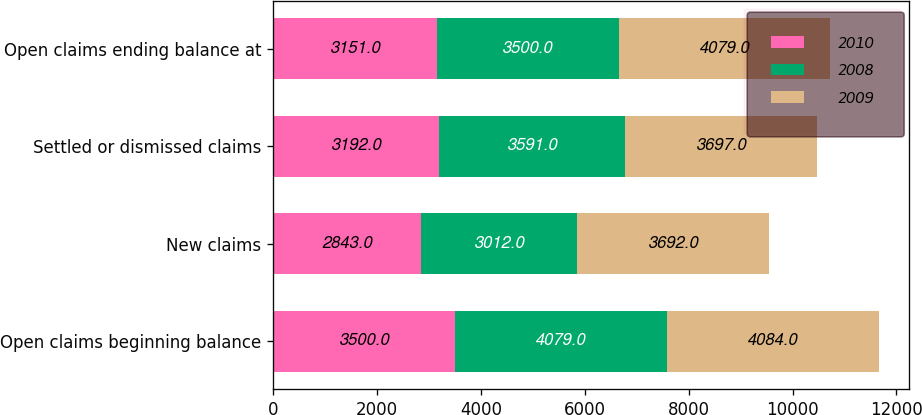<chart> <loc_0><loc_0><loc_500><loc_500><stacked_bar_chart><ecel><fcel>Open claims beginning balance<fcel>New claims<fcel>Settled or dismissed claims<fcel>Open claims ending balance at<nl><fcel>2010<fcel>3500<fcel>2843<fcel>3192<fcel>3151<nl><fcel>2008<fcel>4079<fcel>3012<fcel>3591<fcel>3500<nl><fcel>2009<fcel>4084<fcel>3692<fcel>3697<fcel>4079<nl></chart> 